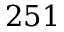<formula> <loc_0><loc_0><loc_500><loc_500>2 5 1</formula> 